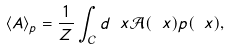<formula> <loc_0><loc_0><loc_500><loc_500>\langle A \rangle _ { p } = \frac { 1 } { Z } \int _ { \mathcal { C } } d \ x { \mathcal { A } } ( \ x ) p ( \ x ) ,</formula> 